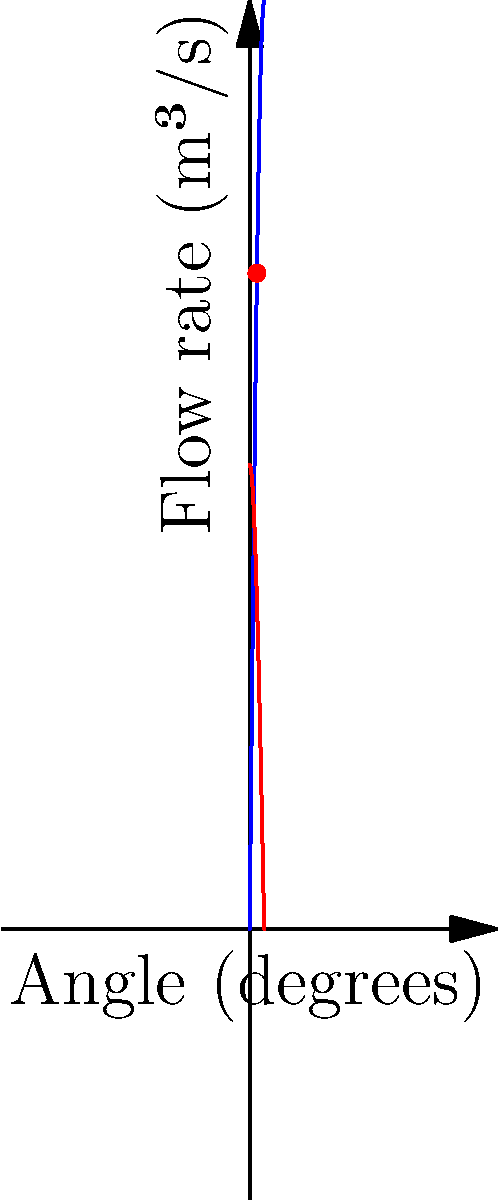As a resident doctor with an appreciation for visual art, imagine you're designing a water feature for a hospital garden inspired by Gorillaz album covers. The spillway's efficiency is crucial for both aesthetics and function. Given the graph showing water flow rate (blue) and spillway efficiency (red) as functions of the spillway angle, what is the optimal angle for maximum efficiency? To find the optimal angle for maximum efficiency, we need to analyze the given graph:

1. The blue curve represents the water flow rate as a function of the spillway angle.
2. The red curve represents the efficiency of the spillway as a function of the angle.
3. The optimal angle is where the efficiency (red curve) reaches its maximum point.

Looking at the red curve (efficiency):

4. It starts high at 0 degrees, decreases as the angle increases, and reaches its minimum at 90 degrees.
5. The maximum point of the efficiency curve occurs at its peak, which is at the y-axis (0 degrees).

However, we need to consider both efficiency and water flow:

6. At 0 degrees, while efficiency is maximum, the water flow rate is zero, which is not practical.
7. As the angle increases, the water flow rate increases, but efficiency decreases.
8. The optimal point is where we balance both factors.

Observing the graph:

9. The red dot on the graph indicates the intersection of the two curves.
10. This intersection point represents the angle where we achieve a balance between efficiency and water flow rate.
11. The x-coordinate of this intersection point is approximately 45 degrees.

Therefore, the optimal angle for the spillway that balances efficiency and water flow rate is 45 degrees.
Answer: 45 degrees 